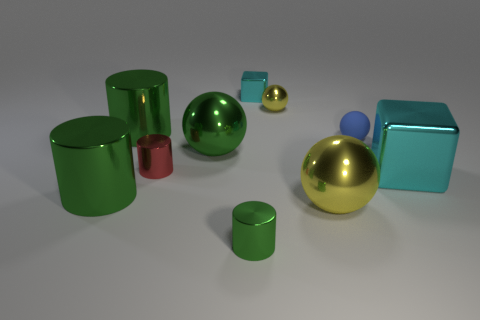Subtract all green balls. How many green cylinders are left? 3 Subtract all green spheres. How many spheres are left? 3 Subtract all small green cylinders. How many cylinders are left? 3 Subtract all brown cylinders. Subtract all yellow cubes. How many cylinders are left? 4 Subtract all spheres. How many objects are left? 6 Subtract 0 blue cylinders. How many objects are left? 10 Subtract all large yellow objects. Subtract all metallic blocks. How many objects are left? 7 Add 3 tiny cyan blocks. How many tiny cyan blocks are left? 4 Add 9 large green blocks. How many large green blocks exist? 9 